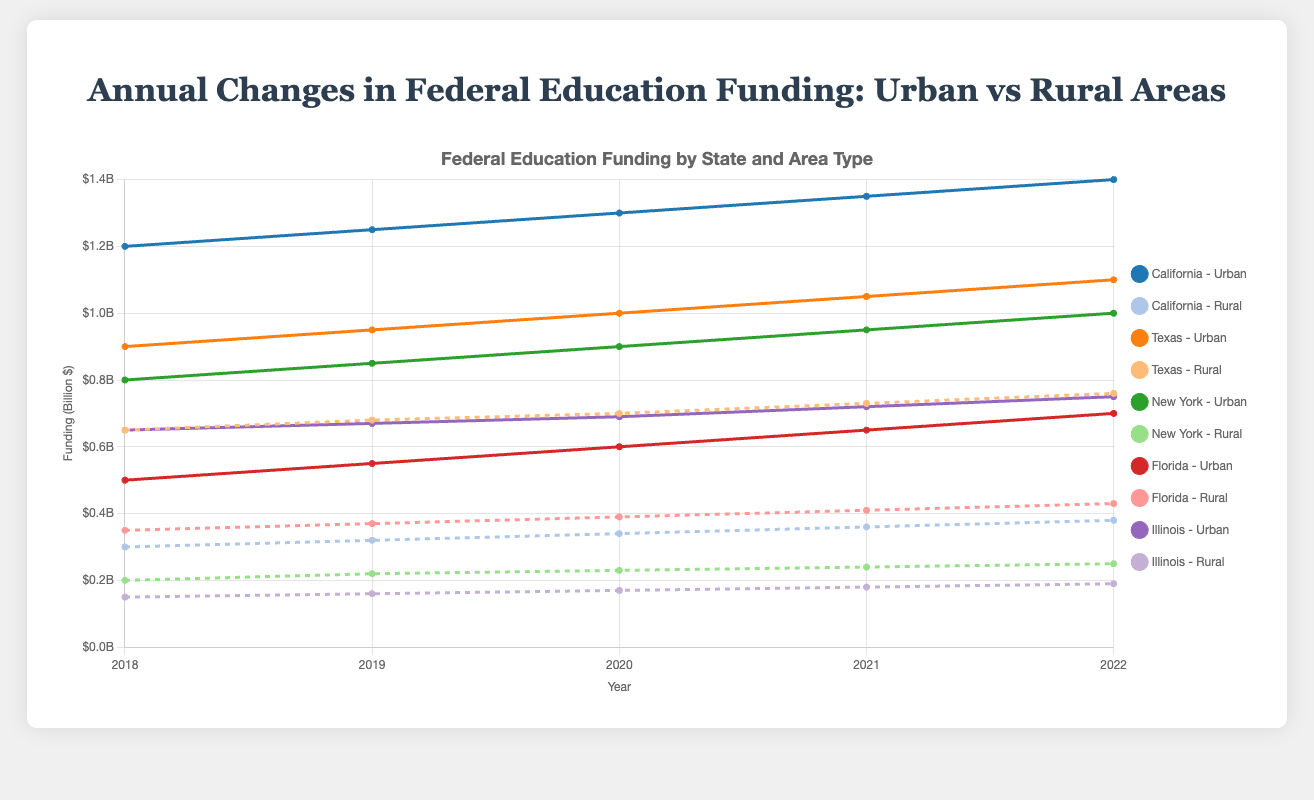What is the total federal funding allocated to urban areas in California and Texas in 2020? First, locate the funding for urban areas in California (1,300,000,000) and Texas (1,000,000,000) for the year 2020. Sum these amounts to get the total federal funding allocated.
Answer: 2,300,000,000 Which state showed the greatest increase in rural funding between 2018 and 2022? Compare the funding increase in rural areas for each state by subtracting the 2018 values from the 2022 values: California (380,000,000 - 300,000,000), Texas (760,000,000 - 650,000,000), New York (250,000,000 - 200,000,000), Florida (430,000,000 - 350,000,000), and Illinois (190,000,000 - 150,000,000), then identify the greatest.
Answer: Texas How did the urban funding in New York change between 2020 and 2021? Look at the urban funding amounts for New York in 2020 (900,000,000) and 2021 (950,000,000). Subtract the 2020 amount from the 2021 amount to determine the change.
Answer: 50,000,000 Which state had the least urban funding in 2022? Compare the urban funding amounts for all states in 2022: California (1,400,000,000), Texas (1,100,000,000), New York (1,000,000,000), Florida (700,000,000), and Illinois (750,000,000). Identify the state with the least funding.
Answer: Florida What is the average annual funding to rural areas in Illinois over the five-year period? Sum the rural funding amounts for Illinois from 2018 to 2022 (150,000,000 + 160,000,000 + 170,000,000 + 180,000,000 + 190,000,000) and then divide by 5 to get the average.
Answer: 170,000,000 Which state received more rural funding in 2019, Texas or Florida? Locate the funding for rural areas in 2019 for Texas (680,000,000) and Florida (370,000,000) and compare the amounts to determine which is greater.
Answer: Texas What trend can be observed in urban funding across all states between 2018 and 2022? Observe the line trends for urban funding across all states, noting whether they generally increase, decrease, or remain constant. Each state’s urban funding shows a generally increasing trend.
Answer: Increasing How much did the federal funding for rural areas in California increase from 2019 to 2020? Locate the rural funding amounts for California in 2019 (320,000,000) and 2020 (340,000,000). Subtract the 2019 amount from the 2020 amount to determine the increase.
Answer: 20,000,000 Which state's urban funding line has the steepest slope between 2021 and 2022? Compare the slopes (rates of change) of the urban funding lines for each state between 2021 and 2022. The slopes can be determined by calculating the differences: California (1,400,000,000 - 1,350,000,000), Texas (1,100,000,000 - 1,050,000,000), New York (1,000,000,000 - 950,000,000), Florida (700,000,000 - 650,000,000), Illinois (750,000,000 - 720,000,000). Identify the steepest slope.
Answer: California How does rural funding in Florida in 2022 compare to rural funding in Illinois in the same year? Compare the rural funding amounts in Florida (430,000,000) and Illinois (190,000,000) in 2022 to determine the relationship (greater than, less than, or equal to).
Answer: Florida's is greater 